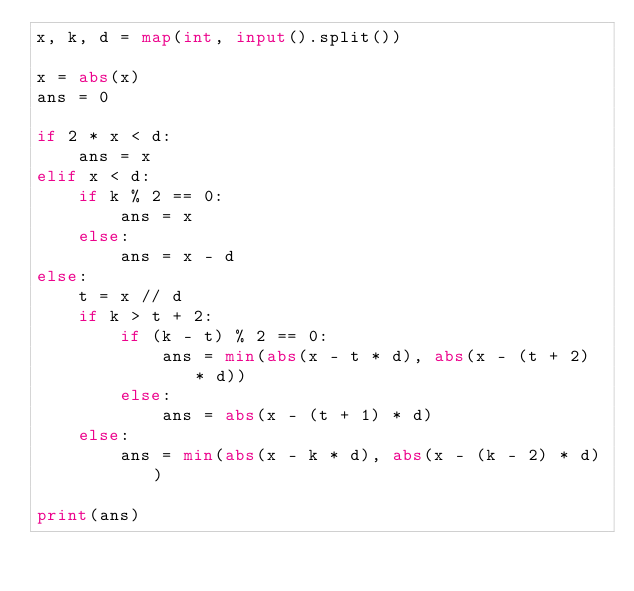Convert code to text. <code><loc_0><loc_0><loc_500><loc_500><_Python_>x, k, d = map(int, input().split())

x = abs(x)
ans = 0

if 2 * x < d:
    ans = x
elif x < d:
    if k % 2 == 0:
        ans = x
    else:
        ans = x - d
else:
    t = x // d
    if k > t + 2:
        if (k - t) % 2 == 0:
            ans = min(abs(x - t * d), abs(x - (t + 2) * d))
        else:
            ans = abs(x - (t + 1) * d)
    else:
        ans = min(abs(x - k * d), abs(x - (k - 2) * d))

print(ans)
</code> 